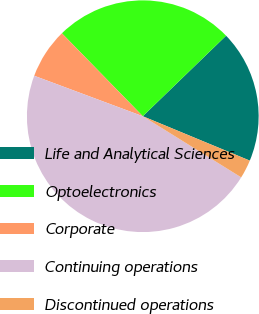<chart> <loc_0><loc_0><loc_500><loc_500><pie_chart><fcel>Life and Analytical Sciences<fcel>Optoelectronics<fcel>Corporate<fcel>Continuing operations<fcel>Discontinued operations<nl><fcel>18.49%<fcel>25.07%<fcel>7.02%<fcel>46.83%<fcel>2.59%<nl></chart> 